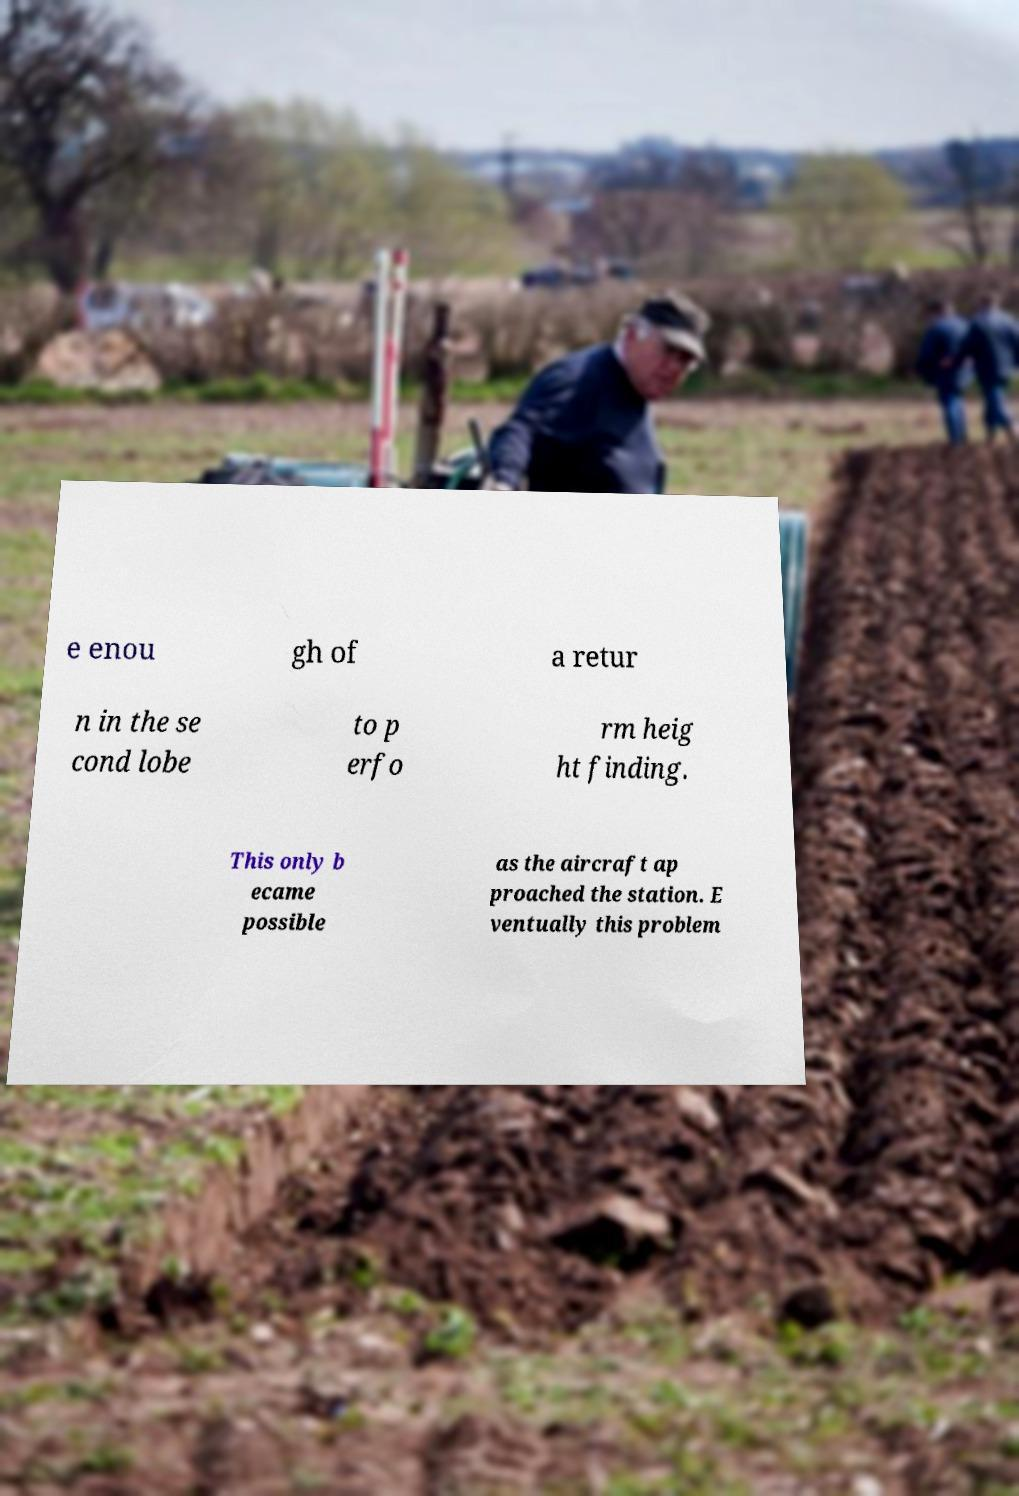Can you accurately transcribe the text from the provided image for me? e enou gh of a retur n in the se cond lobe to p erfo rm heig ht finding. This only b ecame possible as the aircraft ap proached the station. E ventually this problem 